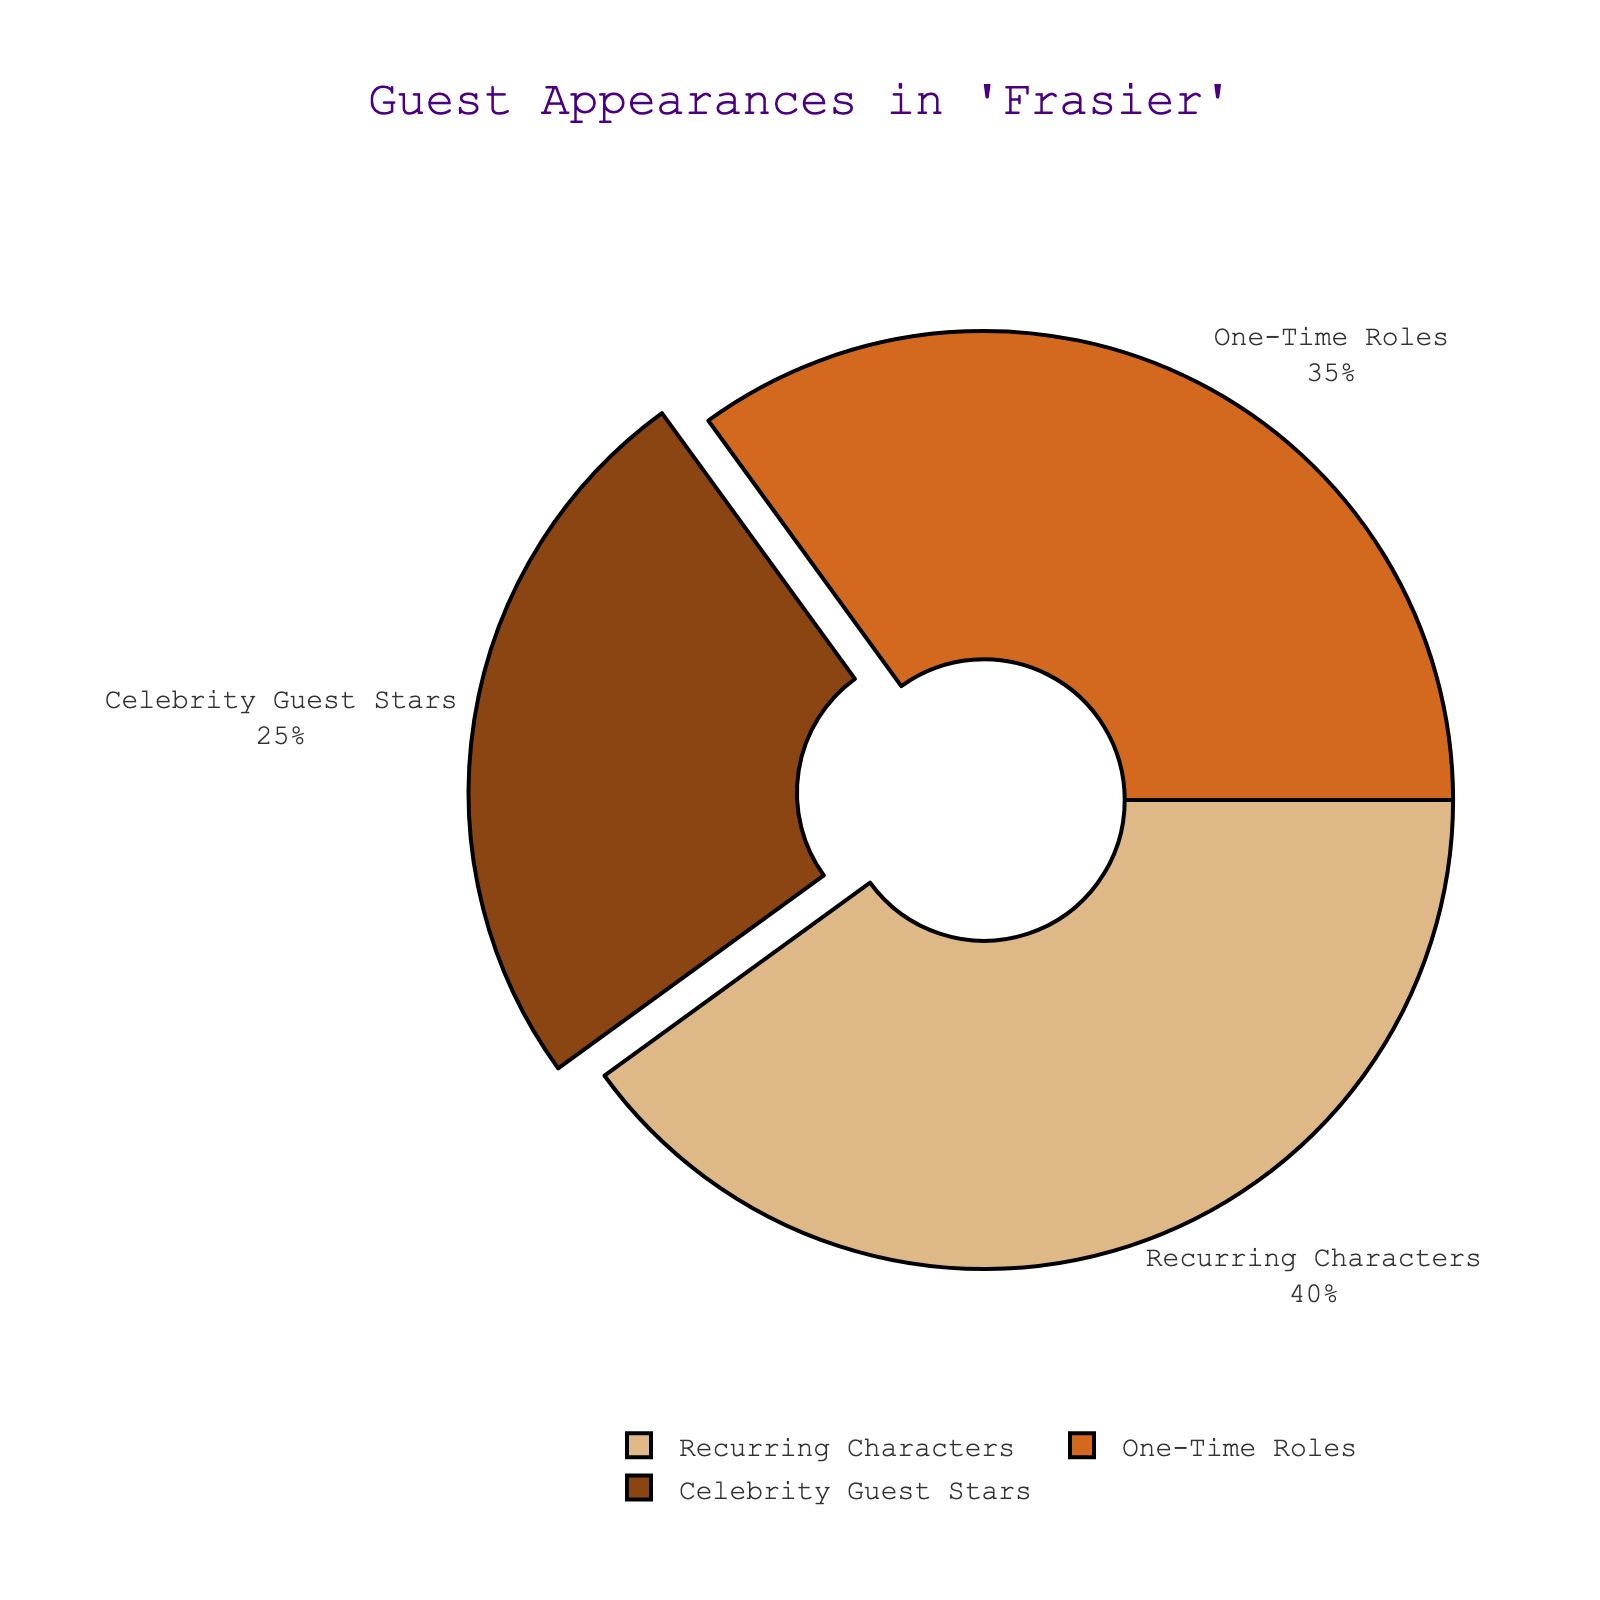What percentage of guest appearances in "Frasier" are recurring characters? The pie chart shows different types of guest appearances: Celebrities, Recurring Characters, and One-Time Roles. Recurring Characters are labeled with 40%.
Answer: 40% Which type of guest appearances has the highest proportion? The pie chart labels indicate percentages for each type of guest appearance: Celebrities (25%), Recurring Characters (40%), and One-Time Roles (35%). The highest percentage is for Recurring Characters at 40%.
Answer: Recurring Characters How many types of guest appearances are shown in the chart? The pie chart displays three different labels: Celebrity Guest Stars, Recurring Characters, and One-Time Roles.
Answer: 3 Is the proportion of Celebrity Guest Stars greater than that of One-Time Roles? The pie chart indicates that Celebrity Guest Stars have a proportion of 25%, whereas One-Time Roles have a proportion of 35%. Since 25% is less than 35%, the proportion of Celebrity Guest Stars is not greater.
Answer: No What is the combined percentage of Celebrity Guest Stars and One-Time Roles? The pie chart shows the percentages for Celebrity Guest Stars (25%) and One-Time Roles (35%). Summing these two percentages gives 25% + 35% = 60%.
Answer: 60% Are Recurring Characters more frequent than the sum of Celebrity Guest Stars and One-Time Roles? The pie chart indicates that Recurring Characters make up 40% of the guest appearances. To find the sum of Celebrity Guest Stars and One-Time Roles: 25% + 35% = 60%. Since 40% is less than 60%, Recurring Characters are not more frequent.
Answer: No What color represents the slice for Celebrity Guest Stars? The pie chart uses colors to represent different types: Celebrity Guest Stars (brownish), Recurring Characters (tan-like), and One-Time Roles (orange-like). Since Celebrity Guest Stars are brownish in color.
Answer: Brown Which type of guest appearance is represented by the largest slice? The pie chart divides the guest appearances by slices. The largest slice corresponds to Recurring Characters, which constitute 40% of guest appearances.
Answer: Recurring Characters If the pie chart's rotation starts at 90 degrees, which segment is pulled out slightly from the rest? The pie chart's rotation starting at 90 degrees positions Recurring Characters at the top and Celebrity Guest Stars to the right. The segment for Celebrity Guest Stars is pulled out slightly.
Answer: Celebrity Guest Stars What visual feature distinguishes Celebrity Guest Stars in the pie chart? The segment for Celebrity Guest Stars is not only colored differently but is also pulled out slightly from the rest of the pie slices, making it visually distinct.
Answer: Pulled out segment 